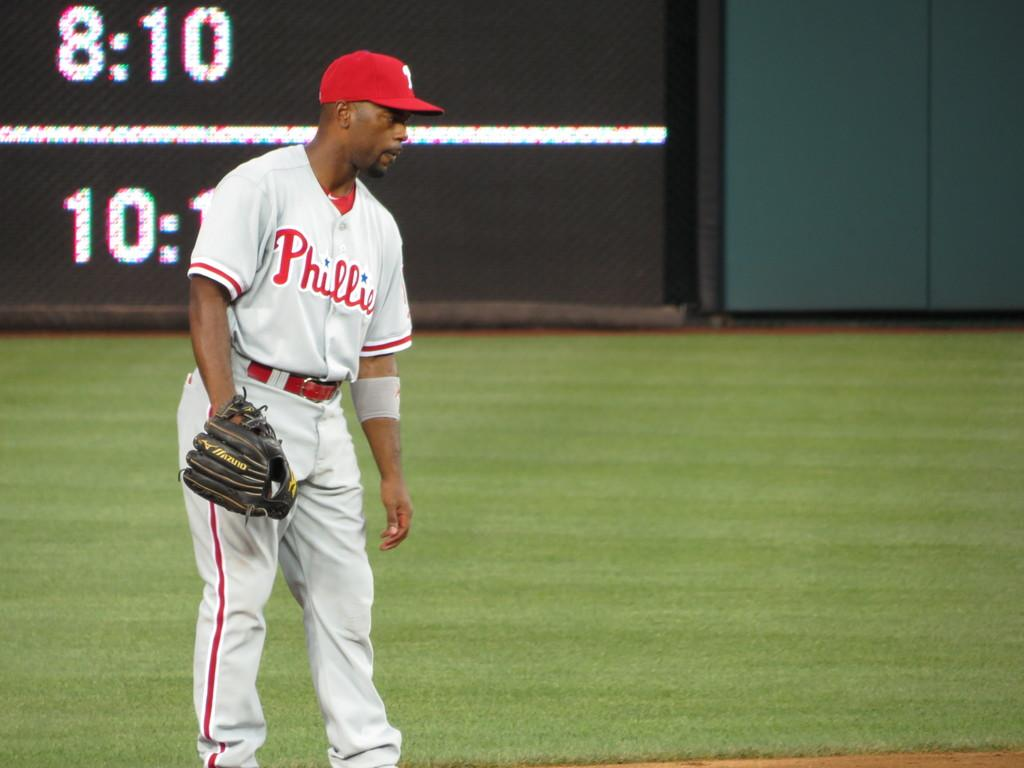<image>
Share a concise interpretation of the image provided. A Phillie's player stands in front of board with 8:10. 